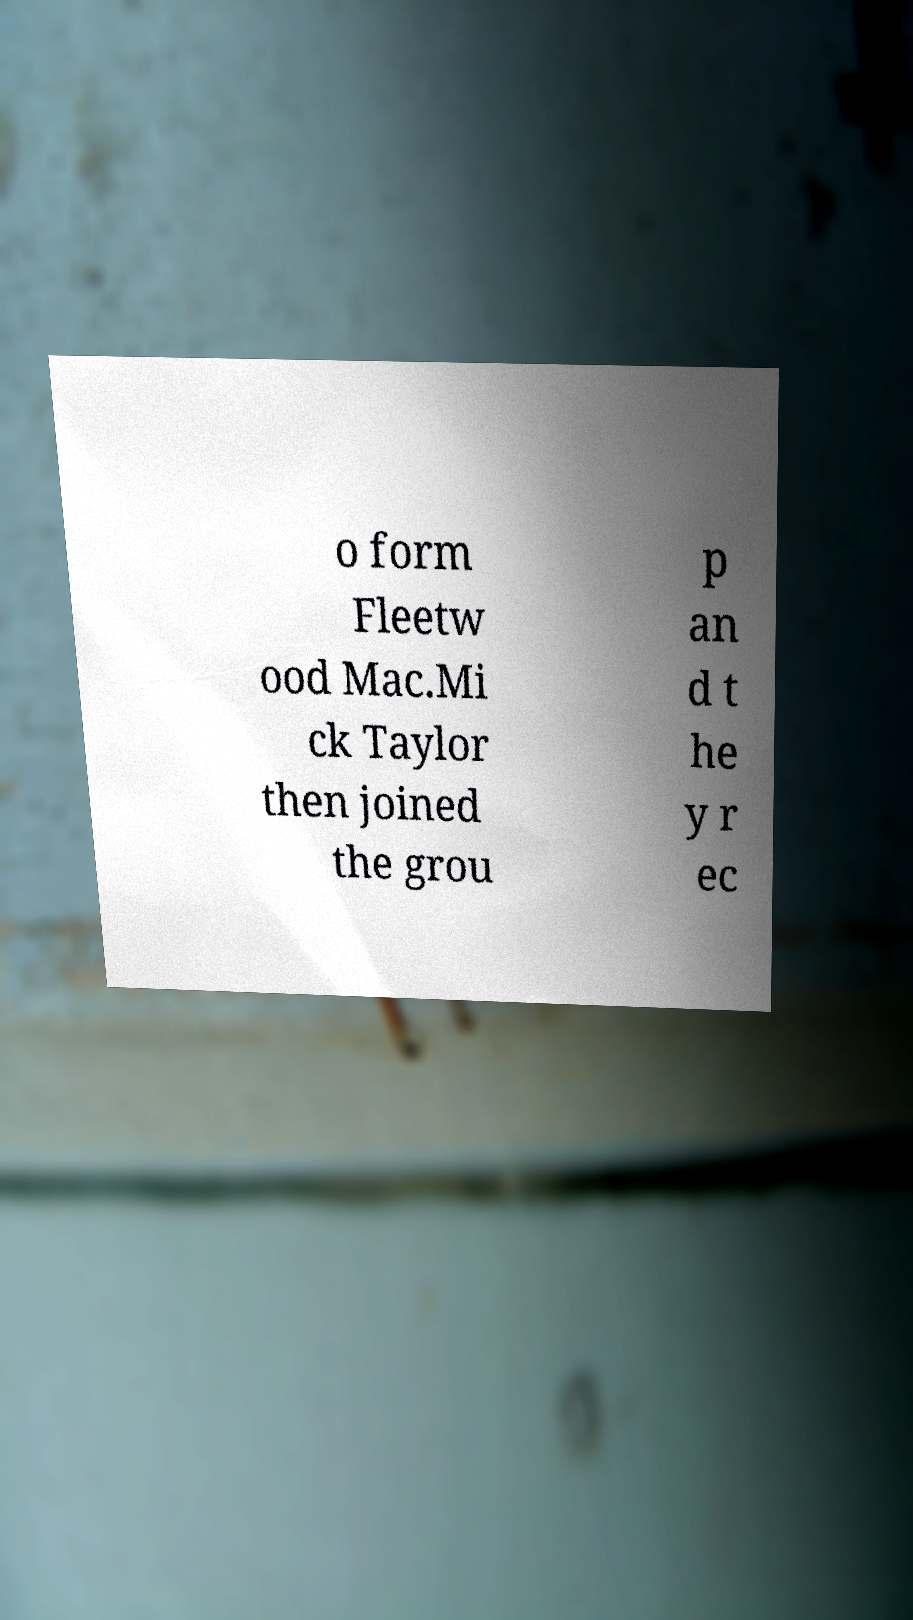Can you accurately transcribe the text from the provided image for me? o form Fleetw ood Mac.Mi ck Taylor then joined the grou p an d t he y r ec 